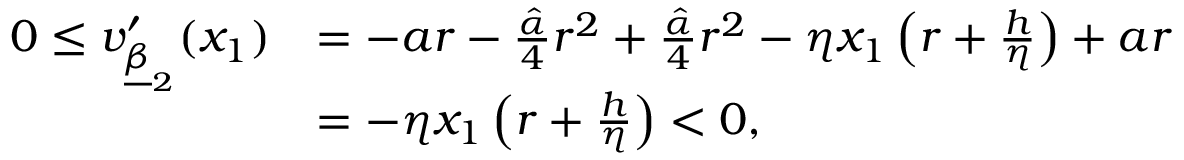Convert formula to latex. <formula><loc_0><loc_0><loc_500><loc_500>\begin{array} { r l } { 0 \leq v _ { \underline { \beta } _ { 2 } } ^ { \prime } ( x _ { 1 } ) } & { = - a r - \frac { \hat { \alpha } } { 4 } r ^ { 2 } + \frac { \hat { \alpha } } { 4 } r ^ { 2 } - \eta x _ { 1 } \left ( r + \frac { h } { \eta } \right ) + a r } \\ & { = - \eta x _ { 1 } \left ( r + \frac { h } { \eta } \right ) < 0 , } \end{array}</formula> 